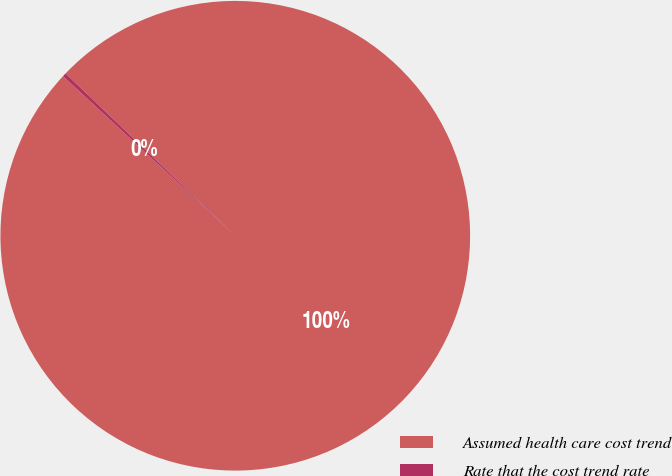<chart> <loc_0><loc_0><loc_500><loc_500><pie_chart><fcel>Assumed health care cost trend<fcel>Rate that the cost trend rate<nl><fcel>99.75%<fcel>0.25%<nl></chart> 